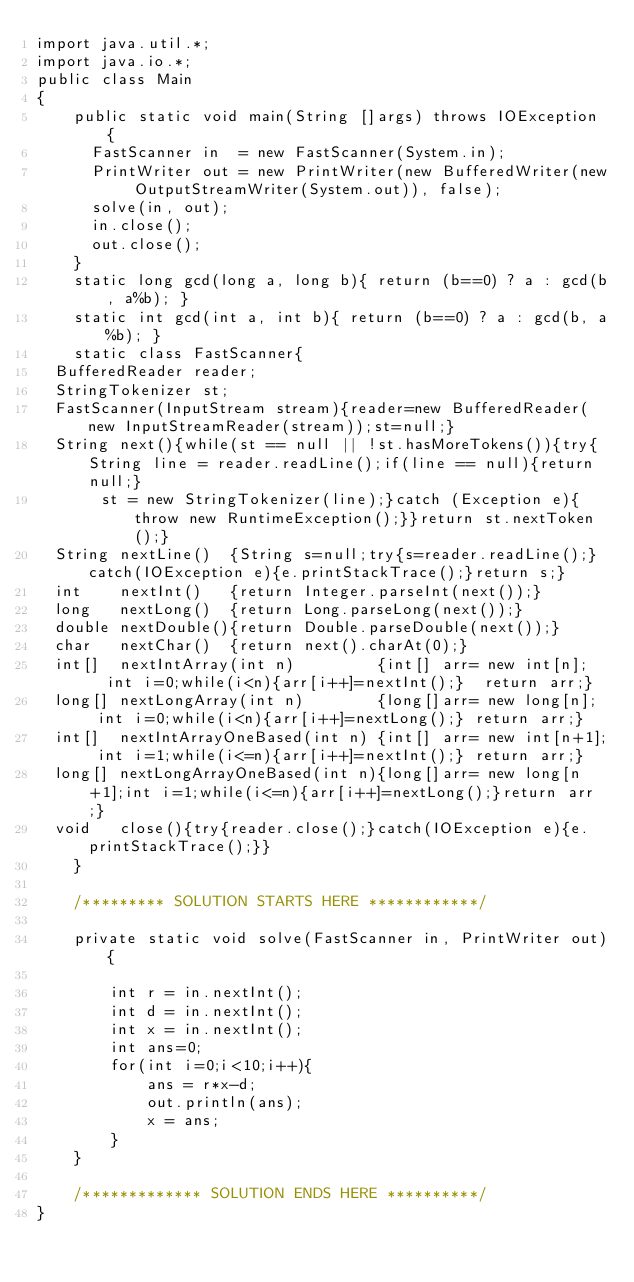Convert code to text. <code><loc_0><loc_0><loc_500><loc_500><_Java_>import java.util.*;
import java.io.*;
public class Main
{
    public static void main(String []args) throws IOException {
    	FastScanner in  = new FastScanner(System.in);
    	PrintWriter out = new PrintWriter(new BufferedWriter(new OutputStreamWriter(System.out)), false);
    	solve(in, out);
    	in.close();
    	out.close();
    }
    static long gcd(long a, long b){ return (b==0) ? a : gcd(b, a%b); }
    static int gcd(int a, int b){ return (b==0) ? a : gcd(b, a%b); }
    static class FastScanner{
	BufferedReader reader;
	StringTokenizer st;
	FastScanner(InputStream stream){reader=new BufferedReader(new InputStreamReader(stream));st=null;}
	String next(){while(st == null || !st.hasMoreTokens()){try{String line = reader.readLine();if(line == null){return null;}
	     st = new StringTokenizer(line);}catch (Exception e){throw new RuntimeException();}}return st.nextToken();}
	String nextLine()  {String s=null;try{s=reader.readLine();}catch(IOException e){e.printStackTrace();}return s;}
	int    nextInt()   {return Integer.parseInt(next());}
	long   nextLong()  {return Long.parseLong(next());}
	double nextDouble(){return Double.parseDouble(next());}
	char   nextChar()  {return next().charAt(0);}
	int[]  nextIntArray(int n)         {int[] arr= new int[n];   int i=0;while(i<n){arr[i++]=nextInt();}  return arr;}
	long[] nextLongArray(int n)        {long[]arr= new long[n];  int i=0;while(i<n){arr[i++]=nextLong();} return arr;}
	int[]  nextIntArrayOneBased(int n) {int[] arr= new int[n+1]; int i=1;while(i<=n){arr[i++]=nextInt();} return arr;}
	long[] nextLongArrayOneBased(int n){long[]arr= new long[n+1];int i=1;while(i<=n){arr[i++]=nextLong();}return arr;}
	void   close(){try{reader.close();}catch(IOException e){e.printStackTrace();}}
    }
    
    /********* SOLUTION STARTS HERE ************/
    
    private static void solve(FastScanner in, PrintWriter out){
        
        int r = in.nextInt();
        int d = in.nextInt();
        int x = in.nextInt();
        int ans=0;
        for(int i=0;i<10;i++){
            ans = r*x-d;
            out.println(ans);
            x = ans;
        }
    }
    
    /************* SOLUTION ENDS HERE **********/
}</code> 